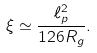Convert formula to latex. <formula><loc_0><loc_0><loc_500><loc_500>\xi \simeq \frac { \ell _ { p } ^ { 2 } } { 1 2 6 R _ { g } } .</formula> 